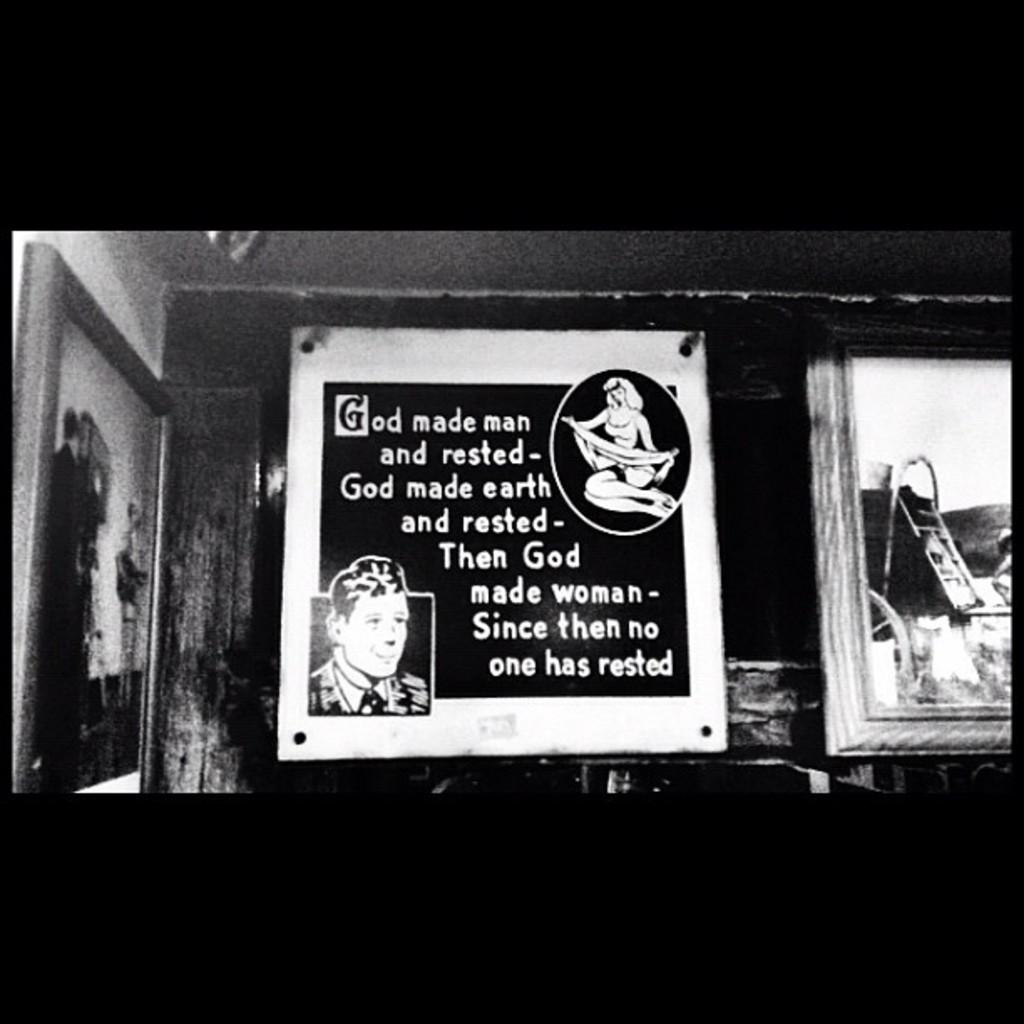Who made men?
Offer a very short reply. God. Who made earth?
Your answer should be compact. God. 